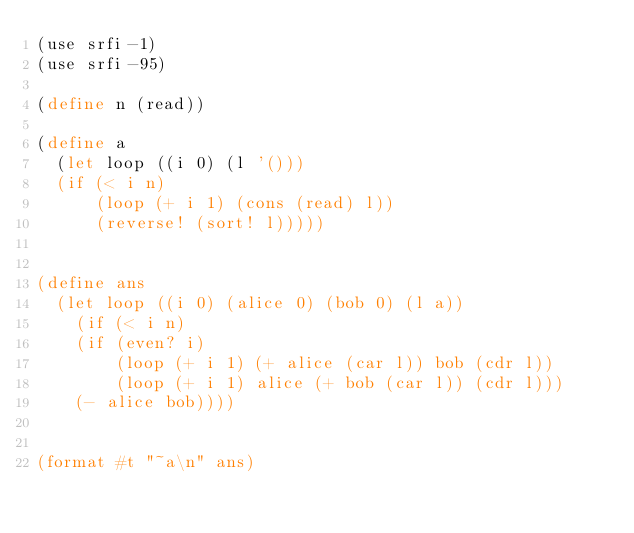<code> <loc_0><loc_0><loc_500><loc_500><_Scheme_>(use srfi-1)
(use srfi-95)

(define n (read))

(define a
  (let loop ((i 0) (l '()))
  (if (< i n)
      (loop (+ i 1) (cons (read) l))
      (reverse! (sort! l)))))
  

(define ans
  (let loop ((i 0) (alice 0) (bob 0) (l a))
    (if (< i n)
	(if (even? i)
	    (loop (+ i 1) (+ alice (car l)) bob (cdr l))
	    (loop (+ i 1) alice (+ bob (car l)) (cdr l)))
	(- alice bob))))
      

(format #t "~a\n" ans)
</code> 